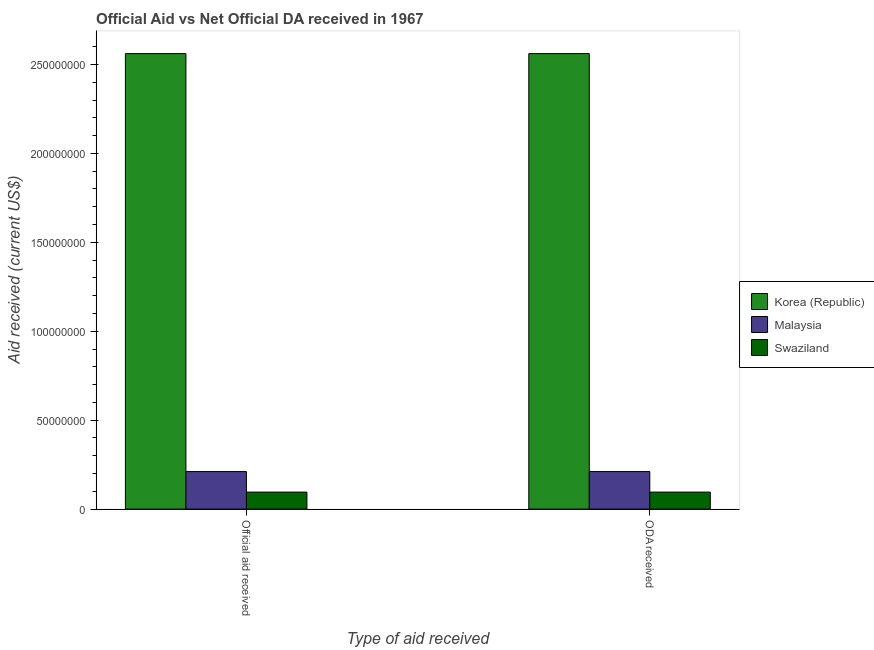How many different coloured bars are there?
Offer a terse response. 3. Are the number of bars per tick equal to the number of legend labels?
Ensure brevity in your answer.  Yes. Are the number of bars on each tick of the X-axis equal?
Keep it short and to the point. Yes. How many bars are there on the 1st tick from the right?
Make the answer very short. 3. What is the label of the 2nd group of bars from the left?
Ensure brevity in your answer.  ODA received. What is the official aid received in Korea (Republic)?
Your response must be concise. 2.56e+08. Across all countries, what is the maximum official aid received?
Give a very brief answer. 2.56e+08. Across all countries, what is the minimum official aid received?
Provide a short and direct response. 9.56e+06. In which country was the official aid received maximum?
Your response must be concise. Korea (Republic). In which country was the official aid received minimum?
Offer a very short reply. Swaziland. What is the total oda received in the graph?
Keep it short and to the point. 2.87e+08. What is the difference between the oda received in Swaziland and that in Korea (Republic)?
Give a very brief answer. -2.47e+08. What is the difference between the official aid received in Swaziland and the oda received in Malaysia?
Provide a succinct answer. -1.15e+07. What is the average official aid received per country?
Your answer should be very brief. 9.56e+07. In how many countries, is the official aid received greater than 10000000 US$?
Give a very brief answer. 2. What is the ratio of the official aid received in Swaziland to that in Korea (Republic)?
Provide a succinct answer. 0.04. What does the 2nd bar from the left in Official aid received represents?
Ensure brevity in your answer.  Malaysia. What does the 2nd bar from the right in ODA received represents?
Offer a very short reply. Malaysia. How many bars are there?
Ensure brevity in your answer.  6. Are all the bars in the graph horizontal?
Your answer should be very brief. No. How many countries are there in the graph?
Your response must be concise. 3. What is the difference between two consecutive major ticks on the Y-axis?
Keep it short and to the point. 5.00e+07. Does the graph contain grids?
Ensure brevity in your answer.  No. How many legend labels are there?
Your response must be concise. 3. What is the title of the graph?
Offer a very short reply. Official Aid vs Net Official DA received in 1967 . What is the label or title of the X-axis?
Keep it short and to the point. Type of aid received. What is the label or title of the Y-axis?
Make the answer very short. Aid received (current US$). What is the Aid received (current US$) in Korea (Republic) in Official aid received?
Ensure brevity in your answer.  2.56e+08. What is the Aid received (current US$) of Malaysia in Official aid received?
Offer a very short reply. 2.11e+07. What is the Aid received (current US$) in Swaziland in Official aid received?
Give a very brief answer. 9.56e+06. What is the Aid received (current US$) of Korea (Republic) in ODA received?
Your answer should be compact. 2.56e+08. What is the Aid received (current US$) of Malaysia in ODA received?
Your response must be concise. 2.11e+07. What is the Aid received (current US$) in Swaziland in ODA received?
Give a very brief answer. 9.56e+06. Across all Type of aid received, what is the maximum Aid received (current US$) of Korea (Republic)?
Ensure brevity in your answer.  2.56e+08. Across all Type of aid received, what is the maximum Aid received (current US$) in Malaysia?
Provide a succinct answer. 2.11e+07. Across all Type of aid received, what is the maximum Aid received (current US$) in Swaziland?
Offer a terse response. 9.56e+06. Across all Type of aid received, what is the minimum Aid received (current US$) of Korea (Republic)?
Provide a short and direct response. 2.56e+08. Across all Type of aid received, what is the minimum Aid received (current US$) of Malaysia?
Offer a very short reply. 2.11e+07. Across all Type of aid received, what is the minimum Aid received (current US$) in Swaziland?
Give a very brief answer. 9.56e+06. What is the total Aid received (current US$) in Korea (Republic) in the graph?
Make the answer very short. 5.12e+08. What is the total Aid received (current US$) in Malaysia in the graph?
Keep it short and to the point. 4.22e+07. What is the total Aid received (current US$) in Swaziland in the graph?
Provide a succinct answer. 1.91e+07. What is the difference between the Aid received (current US$) of Korea (Republic) in Official aid received and that in ODA received?
Offer a terse response. 0. What is the difference between the Aid received (current US$) of Korea (Republic) in Official aid received and the Aid received (current US$) of Malaysia in ODA received?
Make the answer very short. 2.35e+08. What is the difference between the Aid received (current US$) of Korea (Republic) in Official aid received and the Aid received (current US$) of Swaziland in ODA received?
Provide a short and direct response. 2.47e+08. What is the difference between the Aid received (current US$) in Malaysia in Official aid received and the Aid received (current US$) in Swaziland in ODA received?
Give a very brief answer. 1.15e+07. What is the average Aid received (current US$) in Korea (Republic) per Type of aid received?
Make the answer very short. 2.56e+08. What is the average Aid received (current US$) of Malaysia per Type of aid received?
Provide a short and direct response. 2.11e+07. What is the average Aid received (current US$) in Swaziland per Type of aid received?
Offer a terse response. 9.56e+06. What is the difference between the Aid received (current US$) in Korea (Republic) and Aid received (current US$) in Malaysia in Official aid received?
Keep it short and to the point. 2.35e+08. What is the difference between the Aid received (current US$) in Korea (Republic) and Aid received (current US$) in Swaziland in Official aid received?
Your response must be concise. 2.47e+08. What is the difference between the Aid received (current US$) of Malaysia and Aid received (current US$) of Swaziland in Official aid received?
Give a very brief answer. 1.15e+07. What is the difference between the Aid received (current US$) in Korea (Republic) and Aid received (current US$) in Malaysia in ODA received?
Give a very brief answer. 2.35e+08. What is the difference between the Aid received (current US$) of Korea (Republic) and Aid received (current US$) of Swaziland in ODA received?
Offer a terse response. 2.47e+08. What is the difference between the Aid received (current US$) of Malaysia and Aid received (current US$) of Swaziland in ODA received?
Give a very brief answer. 1.15e+07. What is the ratio of the Aid received (current US$) of Korea (Republic) in Official aid received to that in ODA received?
Your response must be concise. 1. What is the ratio of the Aid received (current US$) of Malaysia in Official aid received to that in ODA received?
Keep it short and to the point. 1. What is the ratio of the Aid received (current US$) of Swaziland in Official aid received to that in ODA received?
Ensure brevity in your answer.  1. What is the difference between the highest and the lowest Aid received (current US$) of Korea (Republic)?
Offer a very short reply. 0. What is the difference between the highest and the lowest Aid received (current US$) in Malaysia?
Provide a short and direct response. 0. 